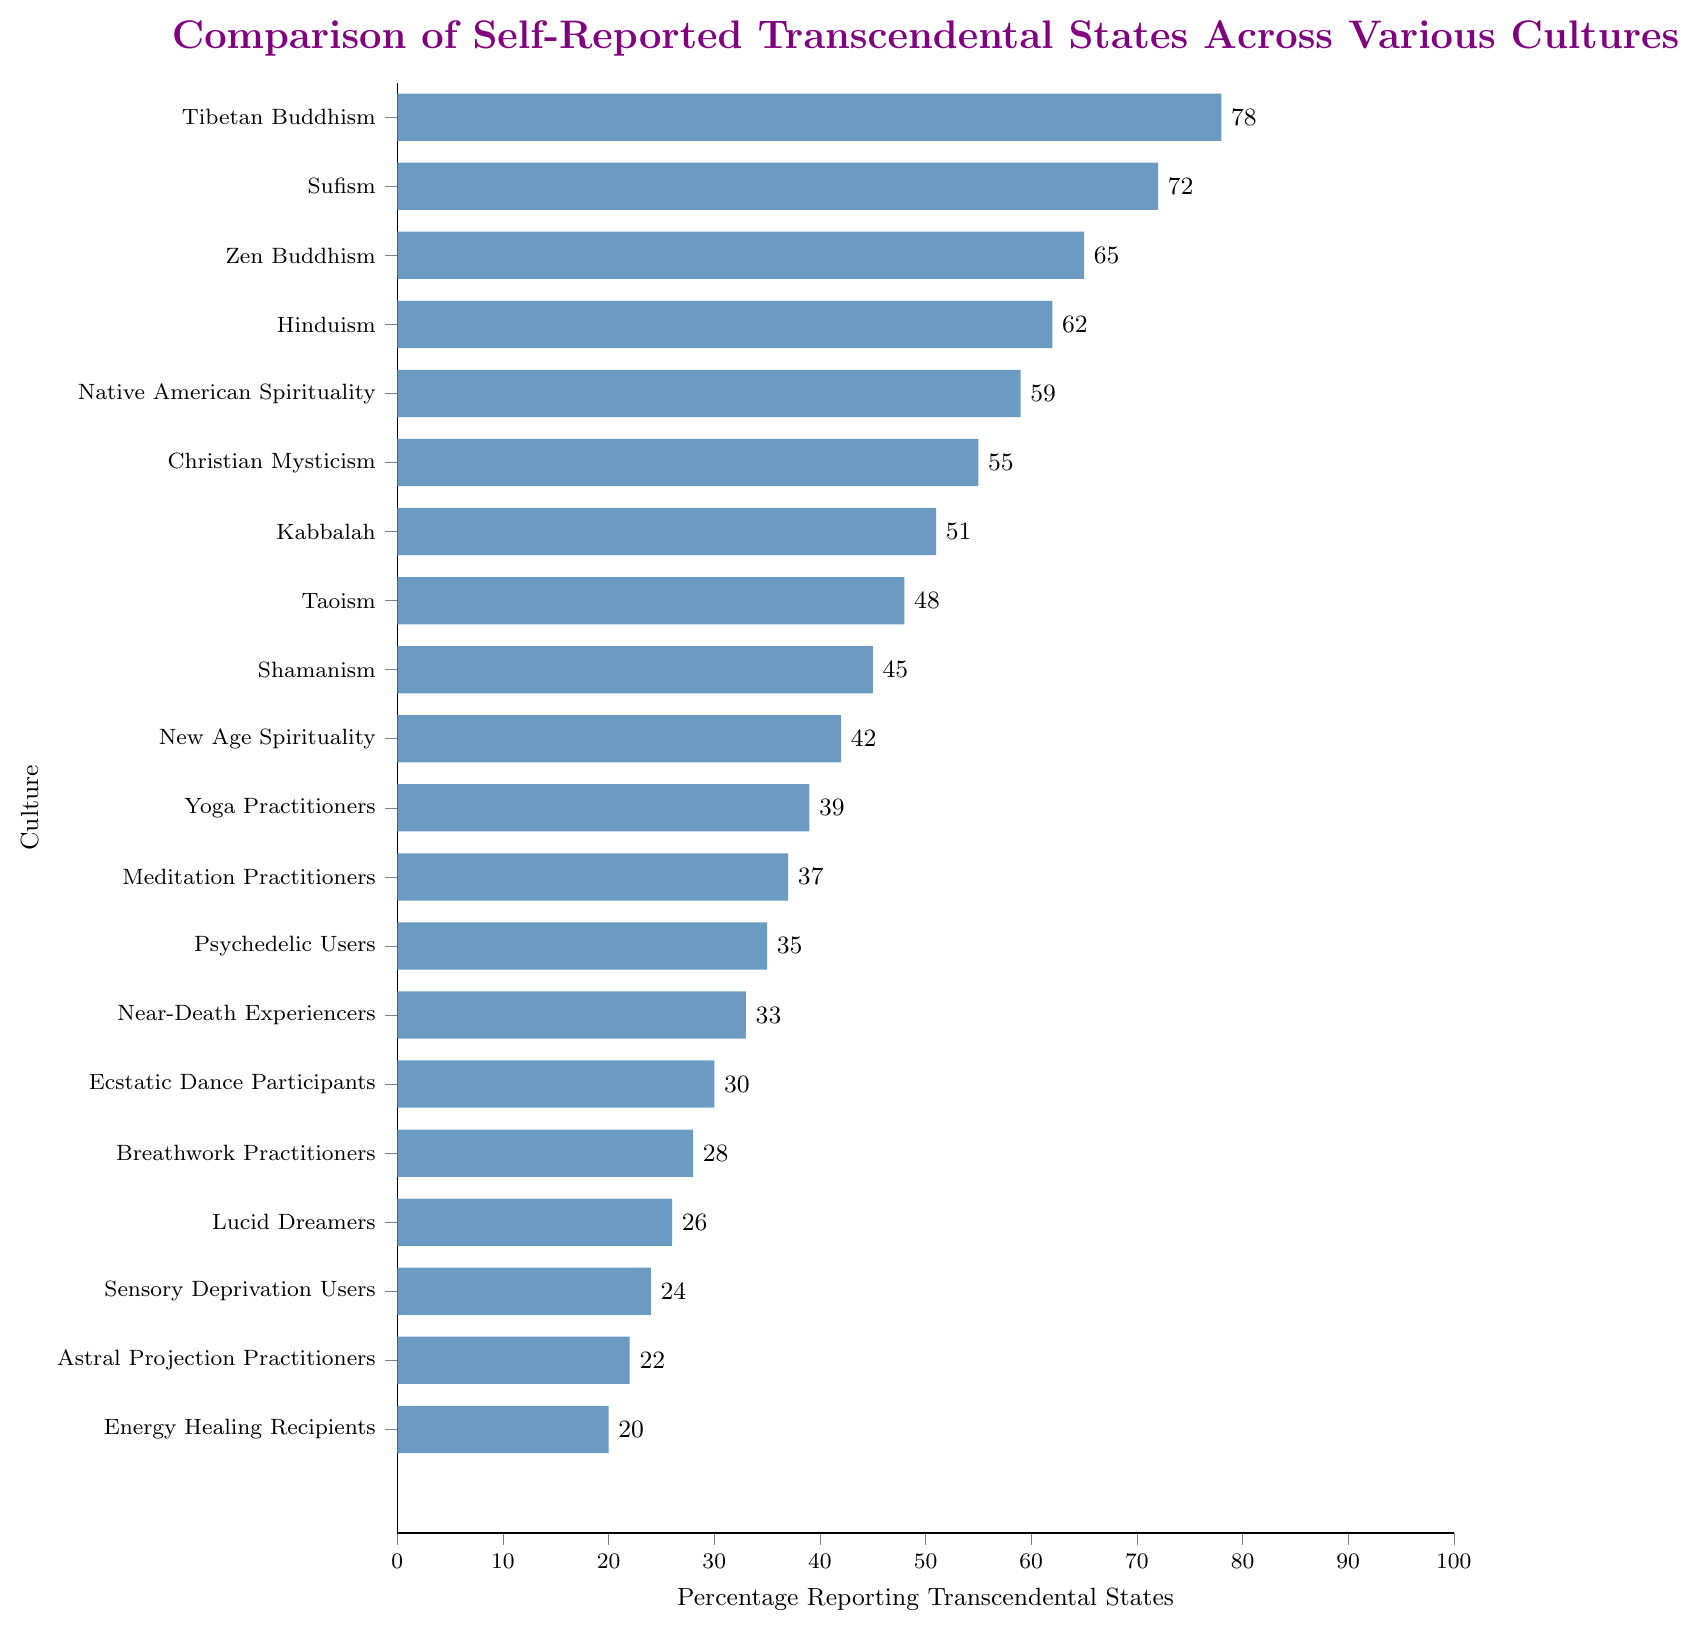What's the highest reported percentage of transcendental states among the cultures? The highest bar represents Tibetan Buddhism, which reaches 78 on the x-axis.
Answer: 78 Which culture has the lowest reported percentage of transcendental states? The bar with the smallest length corresponds to Energy Healing Recipients, indicating 20 on the x-axis.
Answer: Energy Healing Recipients How much higher is the rate of transcendental states reported by Tibetan Buddhism compared to Astral Projection Practitioners? Subtract the percentage of Astral Projection Practitioners (22) from that of Tibetan Buddhism (78). 78 - 22 = 56
Answer: 56 What is the combined percentage of self-reported transcendental states for Sufism, Zen Buddhism, and Hinduism? Sum the percentages: Sufism (72), Zen Buddhism (65), and Hinduism (62). 72 + 65 + 62 = 199
Answer: 199 Which culture reported transcendental states at a rate closest to the average percentage of all cultures listed? First, calculate the average of all provided percentages. Add the percentages and divide by the total number of cultures (20). The average is:
(78+72+65+62+59+55+51+48+45+42+39+37+35+33+30+28+26+24+22+20) / 20 = 43.35. The nearest reported percentage to 43.35 is New Age Spirituality with 42.
Answer: New Age Spirituality Compare the reported transcendental states between Shamanism and New Age Spirituality. Which is higher and by how much? Shamanism reports 45, and New Age Spirituality reports 42. The difference is 45 - 42 = 3. Shamanism reports 3% higher than New Age Spirituality.
Answer: Shamanism by 3 How many cultures report more than 50% of individuals experiencing transcendental states? Count all bars above the 50% mark. The cultures are: Tibetan Buddhism (78), Sufism (72), Zen Buddhism (65), Hinduism (62), Native American Spirituality (59), and Christian Mysticism (55). There are 6 such cultures.
Answer: 6 Which two cultures have the closest reported percentages of transcendental states, and what is the difference? Compare the differences between adjacent values. Christian Mysticism (55) and Kabbalah (51) differ by 4, which is the smallest difference.
Answer: Christian Mysticism and Kabbalah, 4 What percentage do Breathwork Practitioners report, and which two cultures report slightly higher and lower percentages, respectively? Breathwork Practitioners report 28%. Ecstatic Dance Participants report a slightly higher percentage of 30%, and Lucid Dreamers report a slightly lower percentage of 26%.
Answer: 28%, Ecstatic Dance Participants and Lucid Dreamers How does the average reported percentage of transcendental states for cultures above 50% compare to the overall average? First, calculate the average for cultures above 50%: (78+72+65+62+59+55)/6 = 65.17. The overall average, as calculated previously, is 43.35. The average for cultures above 50% is higher than the overall average.
Answer: Above 50%: 65.17, Overall: 43.35 